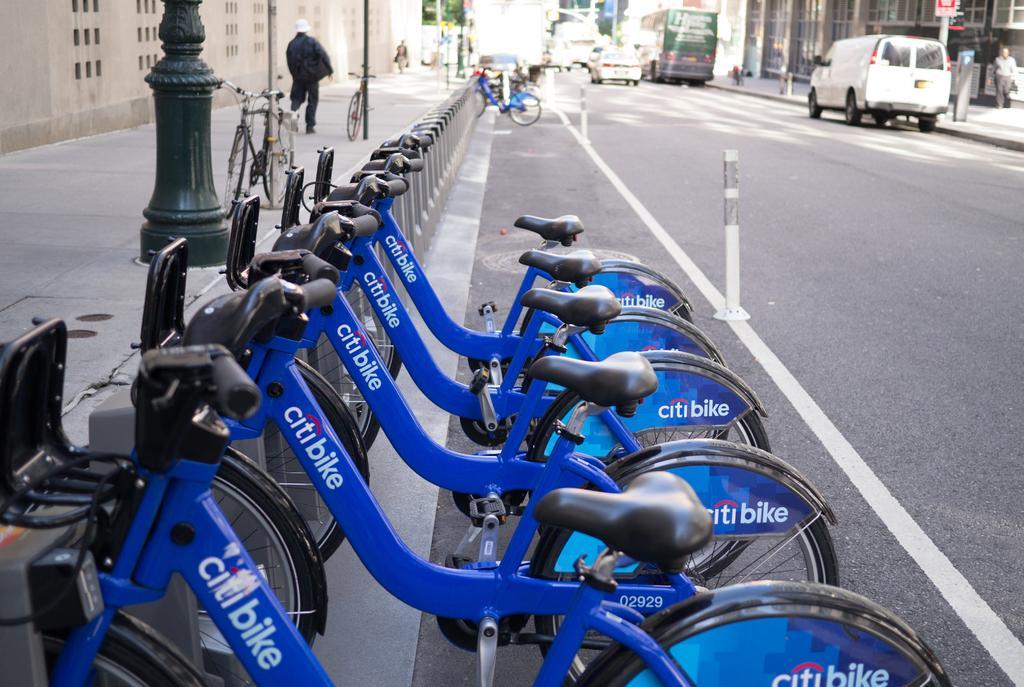Can you describe this image briefly? In this image, we can see some bicycles. There are vehicles on the road in front of the building. There is a person in front of the wall. There are poles in the top left of the image. 